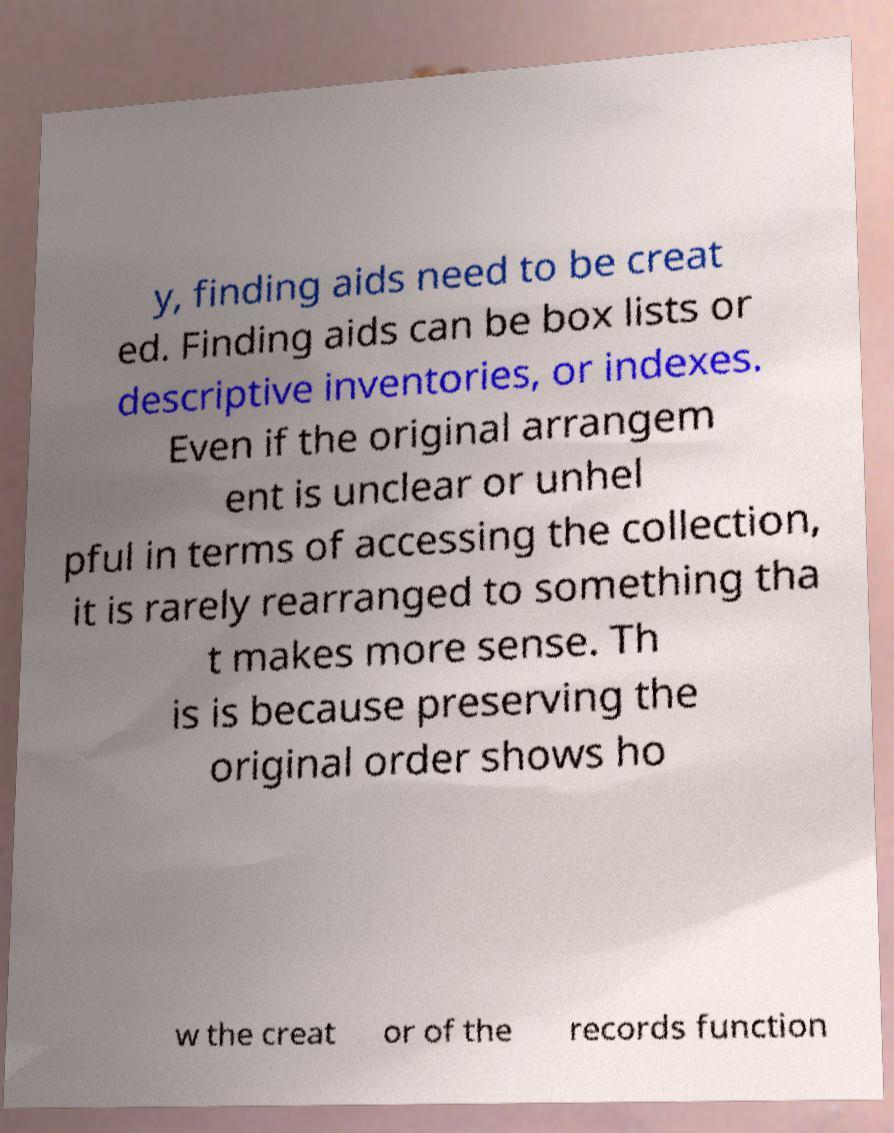Could you extract and type out the text from this image? y, finding aids need to be creat ed. Finding aids can be box lists or descriptive inventories, or indexes. Even if the original arrangem ent is unclear or unhel pful in terms of accessing the collection, it is rarely rearranged to something tha t makes more sense. Th is is because preserving the original order shows ho w the creat or of the records function 